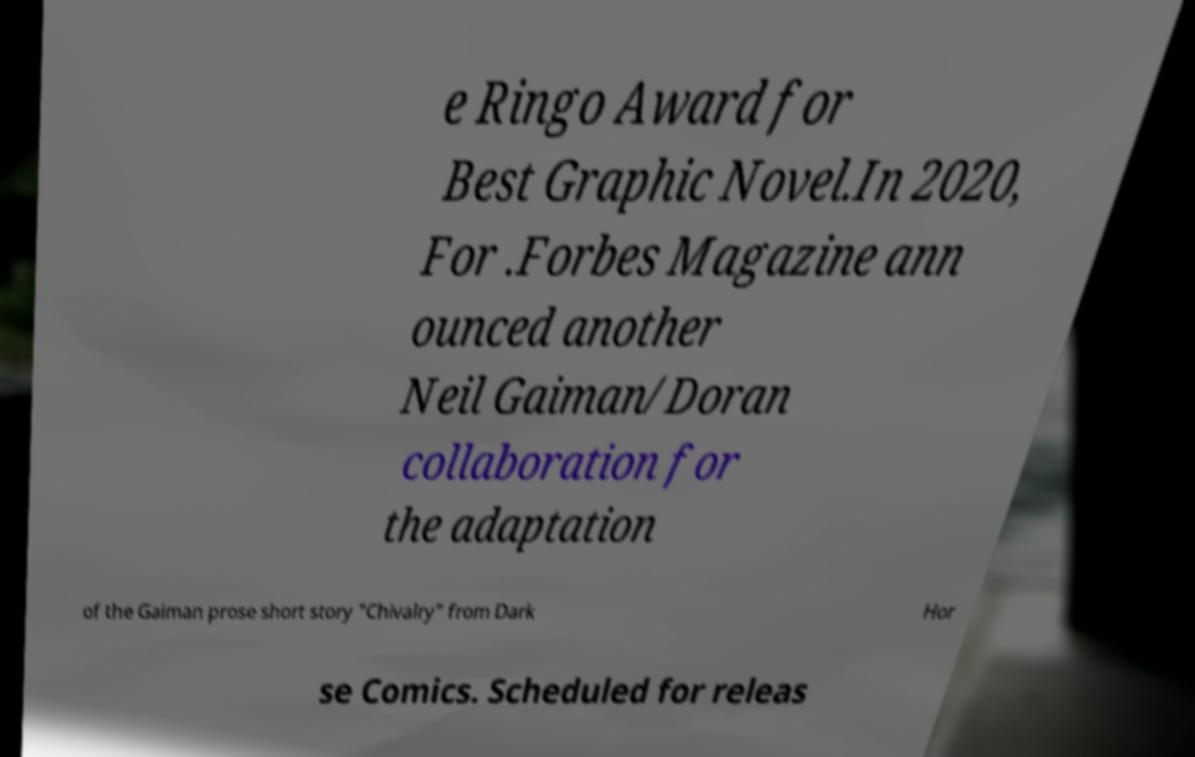Could you assist in decoding the text presented in this image and type it out clearly? e Ringo Award for Best Graphic Novel.In 2020, For .Forbes Magazine ann ounced another Neil Gaiman/Doran collaboration for the adaptation of the Gaiman prose short story "Chivalry" from Dark Hor se Comics. Scheduled for releas 